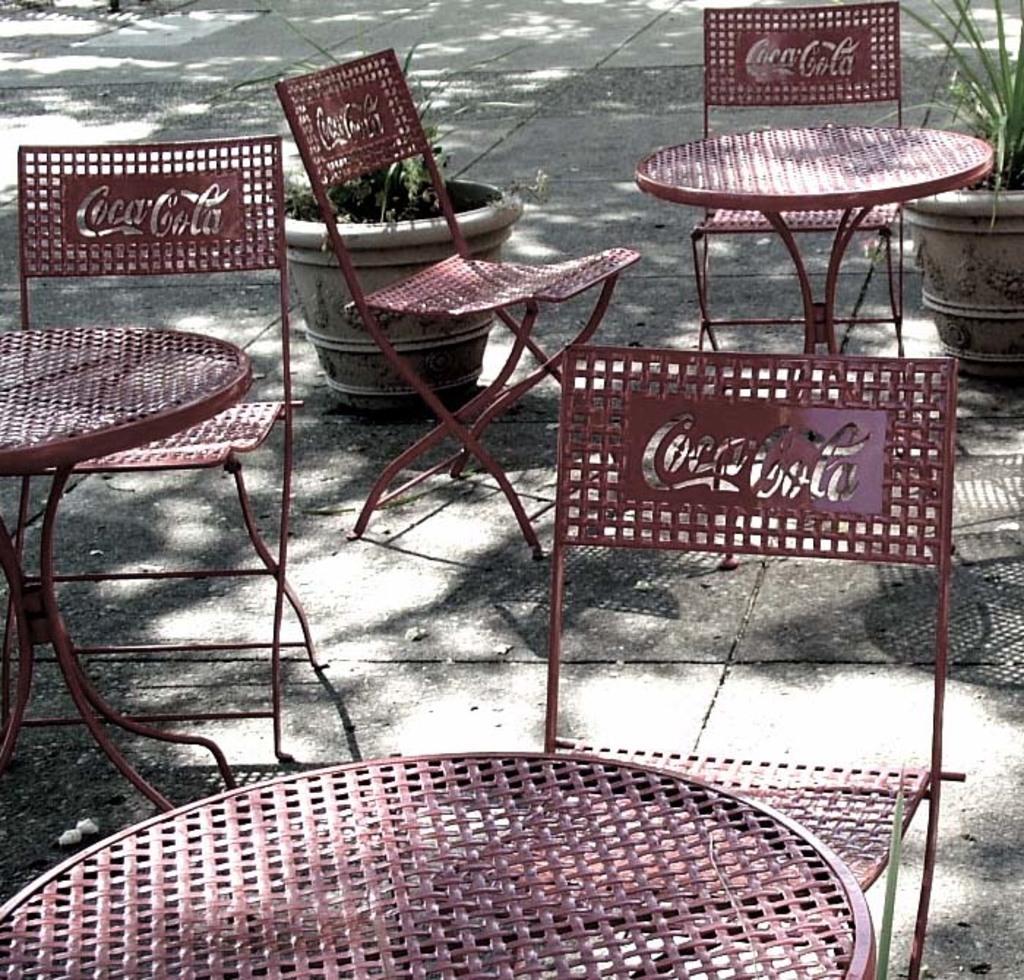How would you summarize this image in a sentence or two? There are tables and chairs. On the chair something is written. In the back there are pots with plants. 